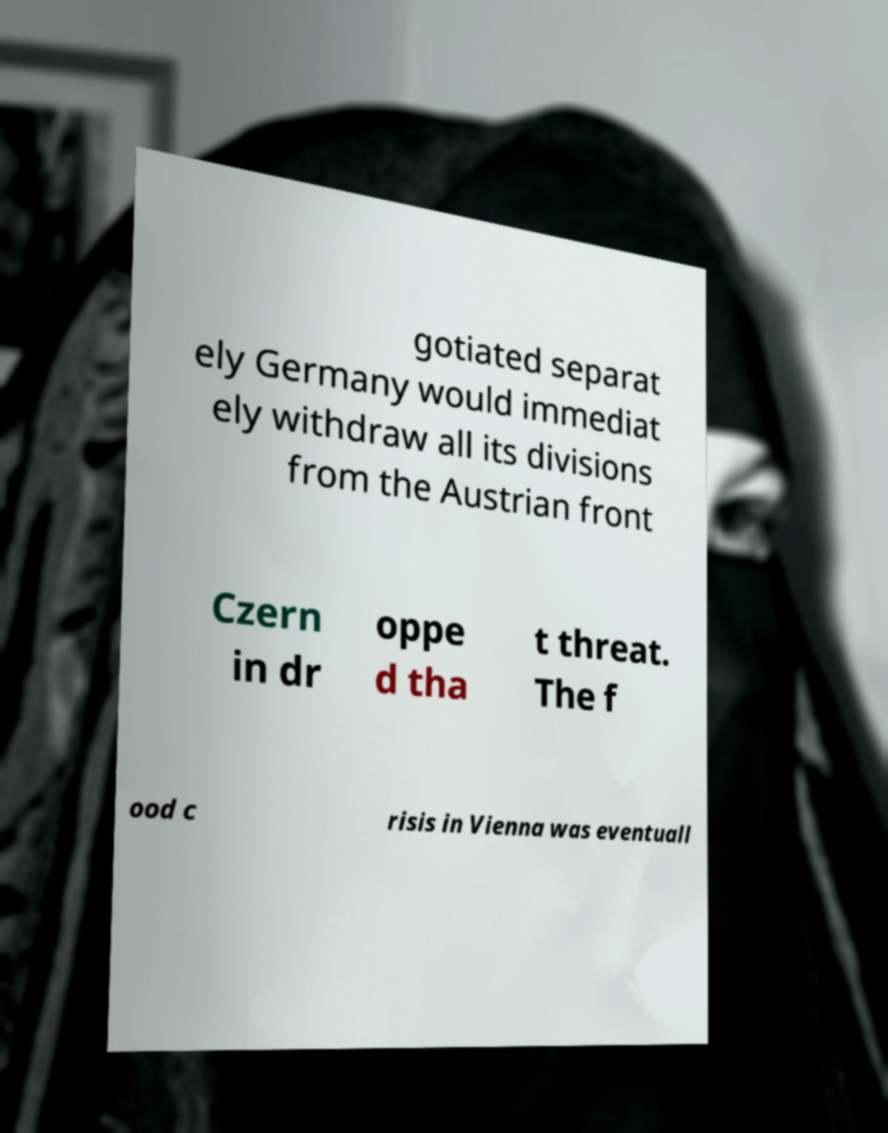For documentation purposes, I need the text within this image transcribed. Could you provide that? gotiated separat ely Germany would immediat ely withdraw all its divisions from the Austrian front Czern in dr oppe d tha t threat. The f ood c risis in Vienna was eventuall 